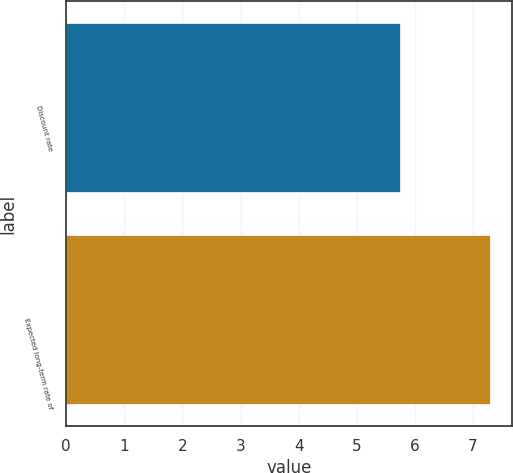<chart> <loc_0><loc_0><loc_500><loc_500><bar_chart><fcel>Discount rate<fcel>Expected long-term rate of<nl><fcel>5.75<fcel>7.3<nl></chart> 